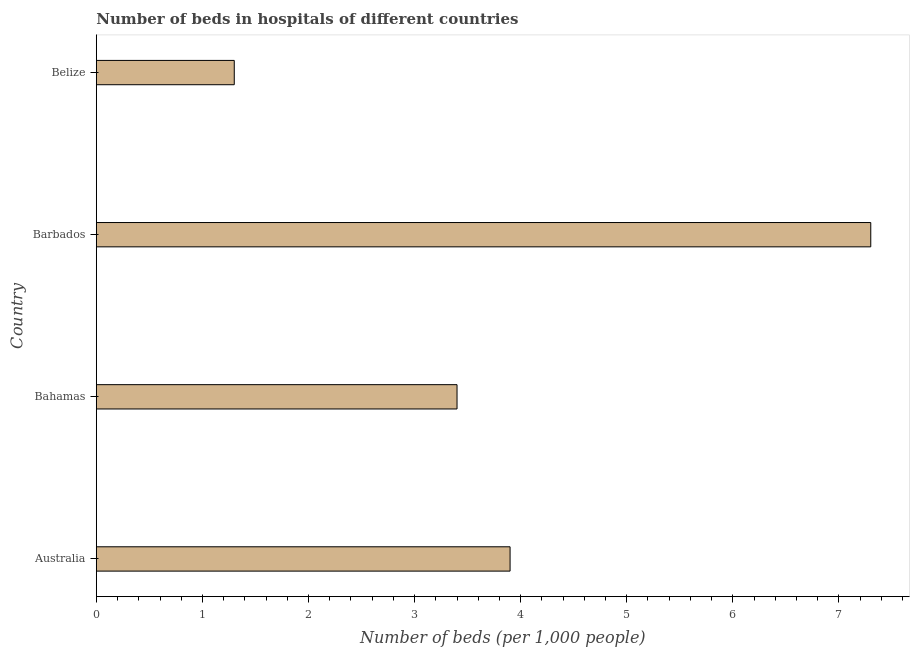What is the title of the graph?
Your response must be concise. Number of beds in hospitals of different countries. What is the label or title of the X-axis?
Your response must be concise. Number of beds (per 1,0 people). What is the label or title of the Y-axis?
Provide a short and direct response. Country. What is the number of hospital beds in Bahamas?
Your answer should be very brief. 3.4. Across all countries, what is the maximum number of hospital beds?
Offer a terse response. 7.3. In which country was the number of hospital beds maximum?
Keep it short and to the point. Barbados. In which country was the number of hospital beds minimum?
Ensure brevity in your answer.  Belize. What is the difference between the number of hospital beds in Australia and Bahamas?
Ensure brevity in your answer.  0.5. What is the average number of hospital beds per country?
Your answer should be very brief. 3.98. What is the median number of hospital beds?
Provide a short and direct response. 3.65. In how many countries, is the number of hospital beds greater than 6.6 %?
Ensure brevity in your answer.  1. What is the ratio of the number of hospital beds in Bahamas to that in Belize?
Your answer should be very brief. 2.62. Is the number of hospital beds in Australia less than that in Bahamas?
Your response must be concise. No. What is the difference between the highest and the second highest number of hospital beds?
Provide a short and direct response. 3.4. How many countries are there in the graph?
Give a very brief answer. 4. What is the difference between two consecutive major ticks on the X-axis?
Offer a terse response. 1. What is the Number of beds (per 1,000 people) in Barbados?
Offer a very short reply. 7.3. What is the Number of beds (per 1,000 people) in Belize?
Make the answer very short. 1.3. What is the difference between the Number of beds (per 1,000 people) in Australia and Barbados?
Offer a very short reply. -3.4. What is the difference between the Number of beds (per 1,000 people) in Bahamas and Barbados?
Provide a short and direct response. -3.9. What is the difference between the Number of beds (per 1,000 people) in Bahamas and Belize?
Offer a very short reply. 2.1. What is the ratio of the Number of beds (per 1,000 people) in Australia to that in Bahamas?
Give a very brief answer. 1.15. What is the ratio of the Number of beds (per 1,000 people) in Australia to that in Barbados?
Keep it short and to the point. 0.53. What is the ratio of the Number of beds (per 1,000 people) in Bahamas to that in Barbados?
Give a very brief answer. 0.47. What is the ratio of the Number of beds (per 1,000 people) in Bahamas to that in Belize?
Provide a short and direct response. 2.62. What is the ratio of the Number of beds (per 1,000 people) in Barbados to that in Belize?
Keep it short and to the point. 5.62. 